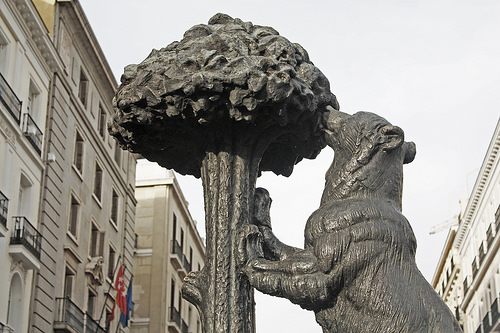<image>
Is the flag next to the statue? No. The flag is not positioned next to the statue. They are located in different areas of the scene. 